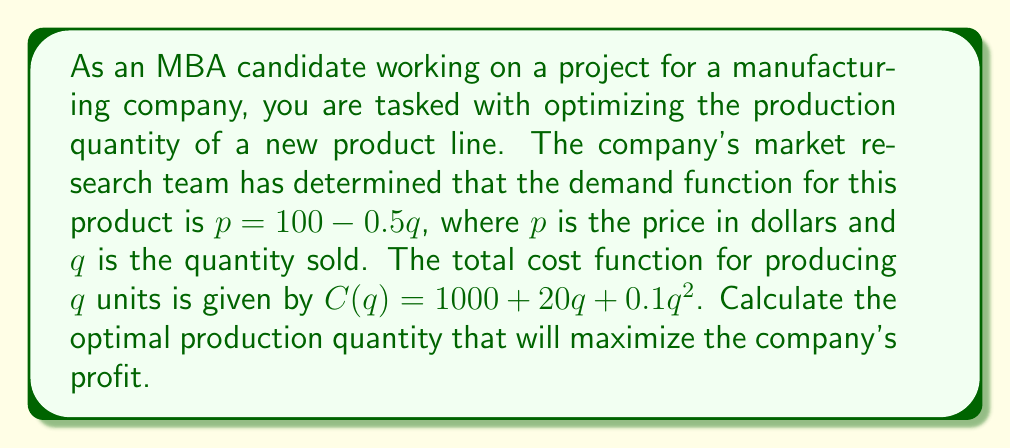Could you help me with this problem? To solve this problem, we'll follow these steps:

1) First, let's define the profit function. Profit is revenue minus cost:
   $$ \Pi(q) = R(q) - C(q) $$

2) Revenue is price times quantity:
   $$ R(q) = pq = (100 - 0.5q)q = 100q - 0.5q^2 $$

3) We're given the cost function:
   $$ C(q) = 1000 + 20q + 0.1q^2 $$

4) Now we can write the profit function:
   $$ \Pi(q) = (100q - 0.5q^2) - (1000 + 20q + 0.1q^2) $$
   $$ \Pi(q) = -1000 + 80q - 0.6q^2 $$

5) To find the maximum profit, we need to find where the derivative of the profit function equals zero:
   $$ \frac{d\Pi}{dq} = 80 - 1.2q $$
   $$ 80 - 1.2q = 0 $$
   $$ -1.2q = -80 $$
   $$ q = \frac{80}{1.2} \approx 66.67 $$

6) To confirm this is a maximum (not a minimum), we can check the second derivative:
   $$ \frac{d^2\Pi}{dq^2} = -1.2 $$
   Since this is negative, we confirm that $q \approx 66.67$ gives a maximum.

7) Since we're dealing with physical units, we need to round to the nearest whole number: 67 units.
Answer: The optimal production quantity to maximize profit is 67 units. 